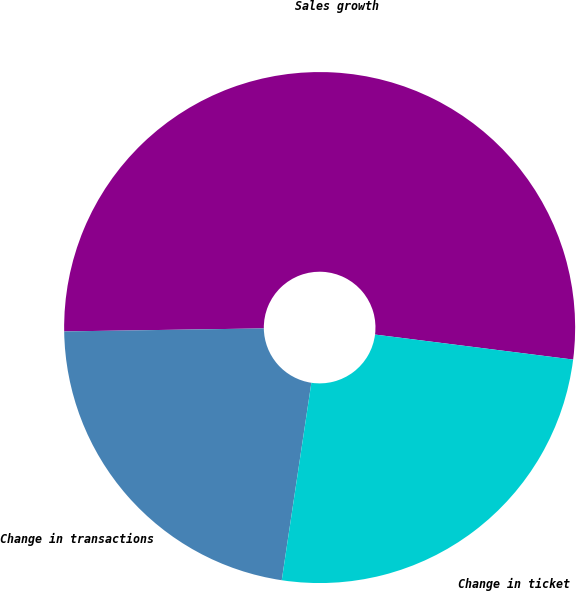<chart> <loc_0><loc_0><loc_500><loc_500><pie_chart><fcel>Sales growth<fcel>Change in transactions<fcel>Change in ticket<nl><fcel>52.24%<fcel>22.39%<fcel>25.37%<nl></chart> 